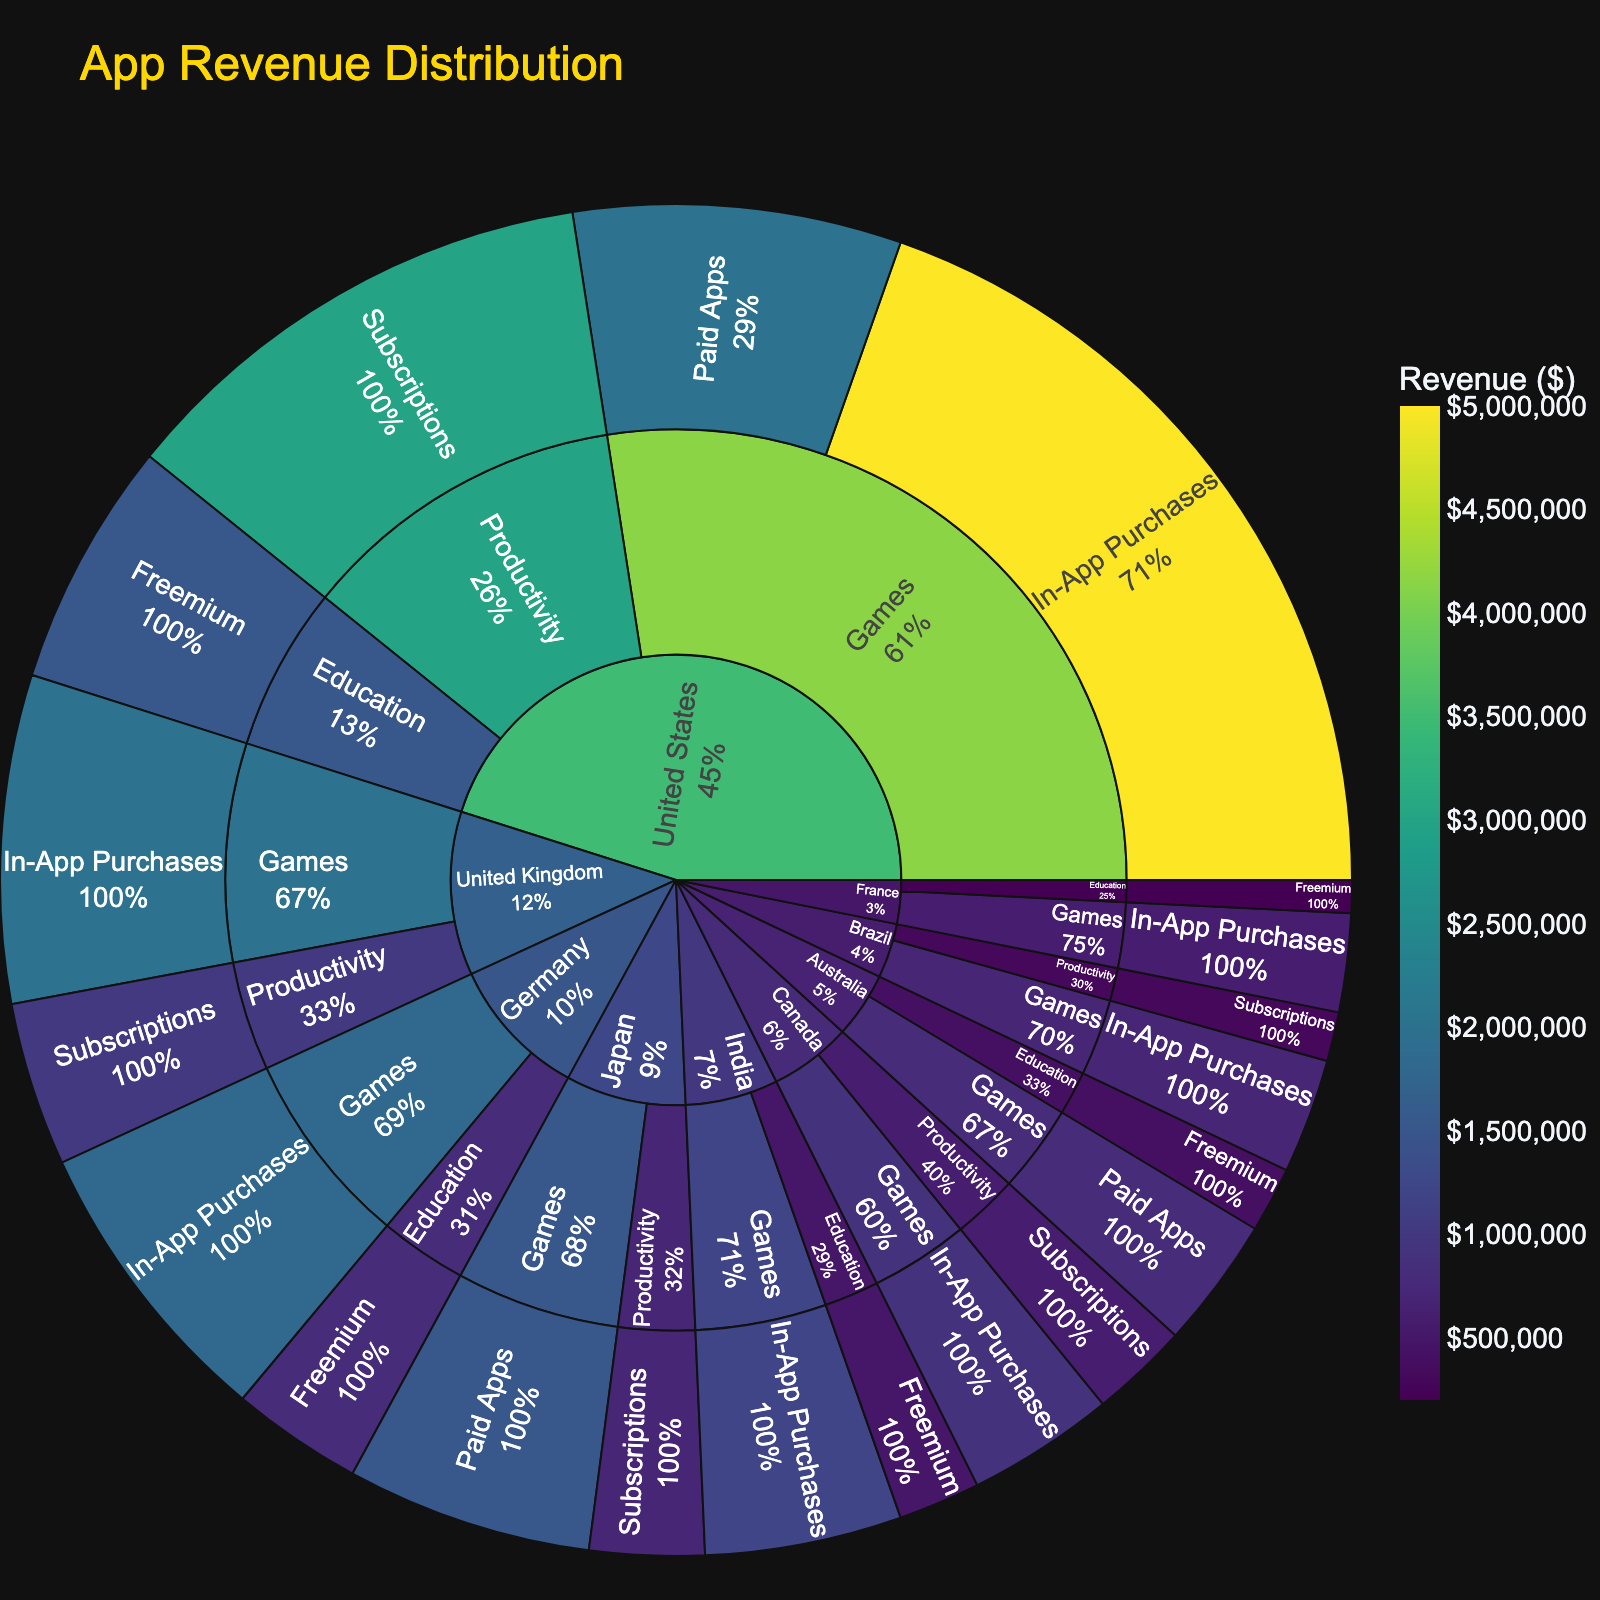What is the title of the figure? The title is usually located at the top of the figure. This figure has "App Revenue Distribution" as its title.
Answer: App Revenue Distribution Which country generates the highest app revenue? Examine the size of the segments for each country. The United States has the largest segment, indicating the highest revenue.
Answer: United States In which category does the United States generate the highest revenue? Look at the sub-segments within the United States segment. The Games category has the largest sub-segment.
Answer: Games Compare the revenue generated from In-App Purchases in the United States and the United Kingdom. Which one is higher? Locate the In-App Purchases segments within the Games category for both countries. The United States' segment is larger.
Answer: United States What is the total revenue generated by Canada? Sum the values for each category within Canada. Canada has Games (900,000) and Productivity (600,000), so the total is 900,000 + 600,000 = 1,500,000.
Answer: 1,500,000 Which monetization model contributes the least to the Education category worldwide? Compare the sizes of the monetization segments within the Education category. The smallest segment appears to be Freemium in Australia.
Answer: Freemium (Australia) How does the revenue from Subscriptions in Germany compare to the same in Japan? Locate the Subscriptions segment in Productivity for both Germany and Japan. Japan’s segment is smaller than Germany’s.
Answer: Germany What percentage of total app revenue in India comes from In-App Purchases? The revenue from In-App Purchases in India is 1,200,000. Sum the total revenue for India, which is In-App Purchases (1,200,000) + Freemium (500,000) = 1,700,000. The percentage is (1,200,000 / 1,700,000) * 100 = 70.59%.
Answer: 70.59% What is the revenue difference between Games and Productivity categories in Australia? Subtract the revenue for the Productivity category from the Games category in Australia. Games (800,000) - Education (400,000) = 400,000.
Answer: 400,000 Which monetization model generates the highest revenue across all countries? By examining the monetization segments, In-App Purchases in the Games category appears to be the most significant contributor overall.
Answer: In-App Purchases 